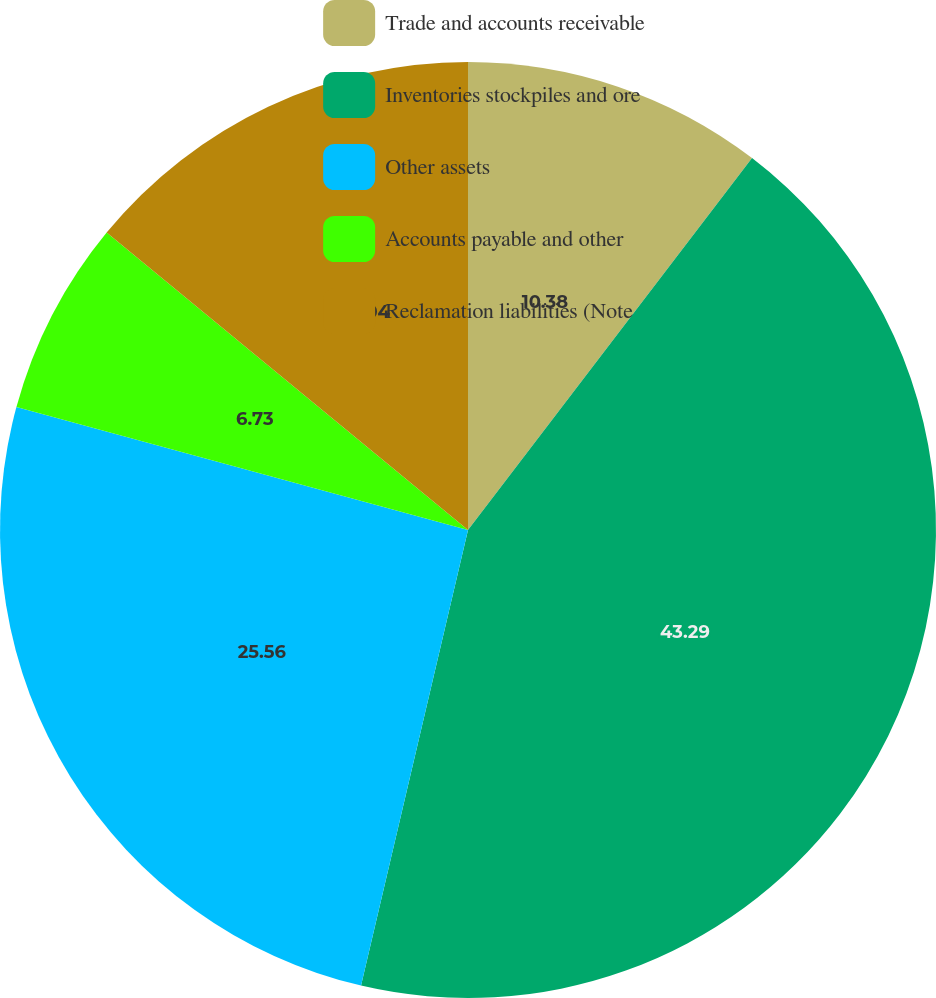<chart> <loc_0><loc_0><loc_500><loc_500><pie_chart><fcel>Trade and accounts receivable<fcel>Inventories stockpiles and ore<fcel>Other assets<fcel>Accounts payable and other<fcel>Reclamation liabilities (Note<nl><fcel>10.38%<fcel>43.29%<fcel>25.56%<fcel>6.73%<fcel>14.04%<nl></chart> 